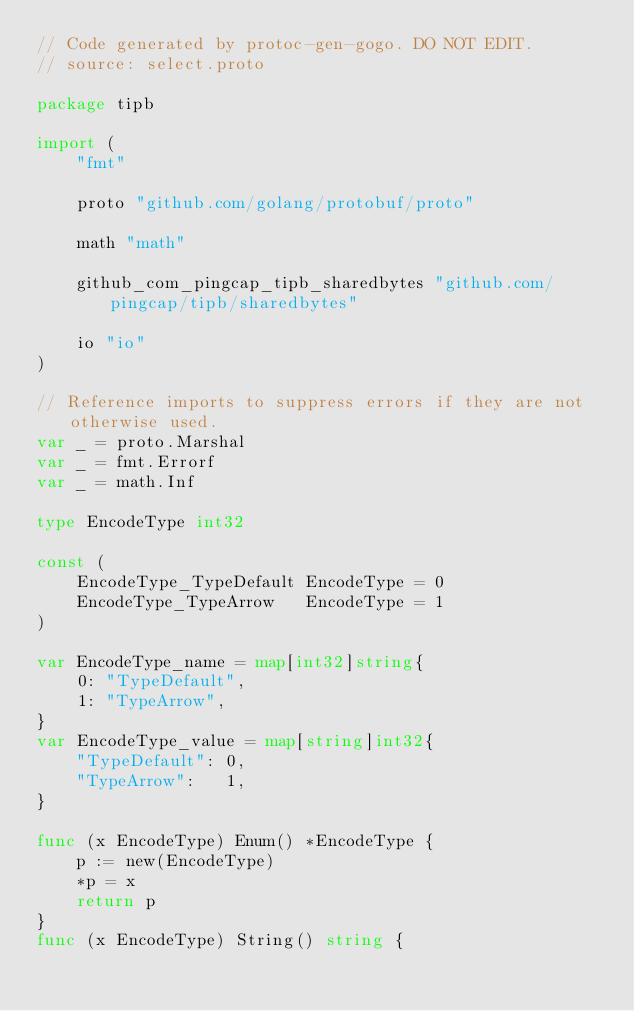Convert code to text. <code><loc_0><loc_0><loc_500><loc_500><_Go_>// Code generated by protoc-gen-gogo. DO NOT EDIT.
// source: select.proto

package tipb

import (
	"fmt"

	proto "github.com/golang/protobuf/proto"

	math "math"

	github_com_pingcap_tipb_sharedbytes "github.com/pingcap/tipb/sharedbytes"

	io "io"
)

// Reference imports to suppress errors if they are not otherwise used.
var _ = proto.Marshal
var _ = fmt.Errorf
var _ = math.Inf

type EncodeType int32

const (
	EncodeType_TypeDefault EncodeType = 0
	EncodeType_TypeArrow   EncodeType = 1
)

var EncodeType_name = map[int32]string{
	0: "TypeDefault",
	1: "TypeArrow",
}
var EncodeType_value = map[string]int32{
	"TypeDefault": 0,
	"TypeArrow":   1,
}

func (x EncodeType) Enum() *EncodeType {
	p := new(EncodeType)
	*p = x
	return p
}
func (x EncodeType) String() string {</code> 